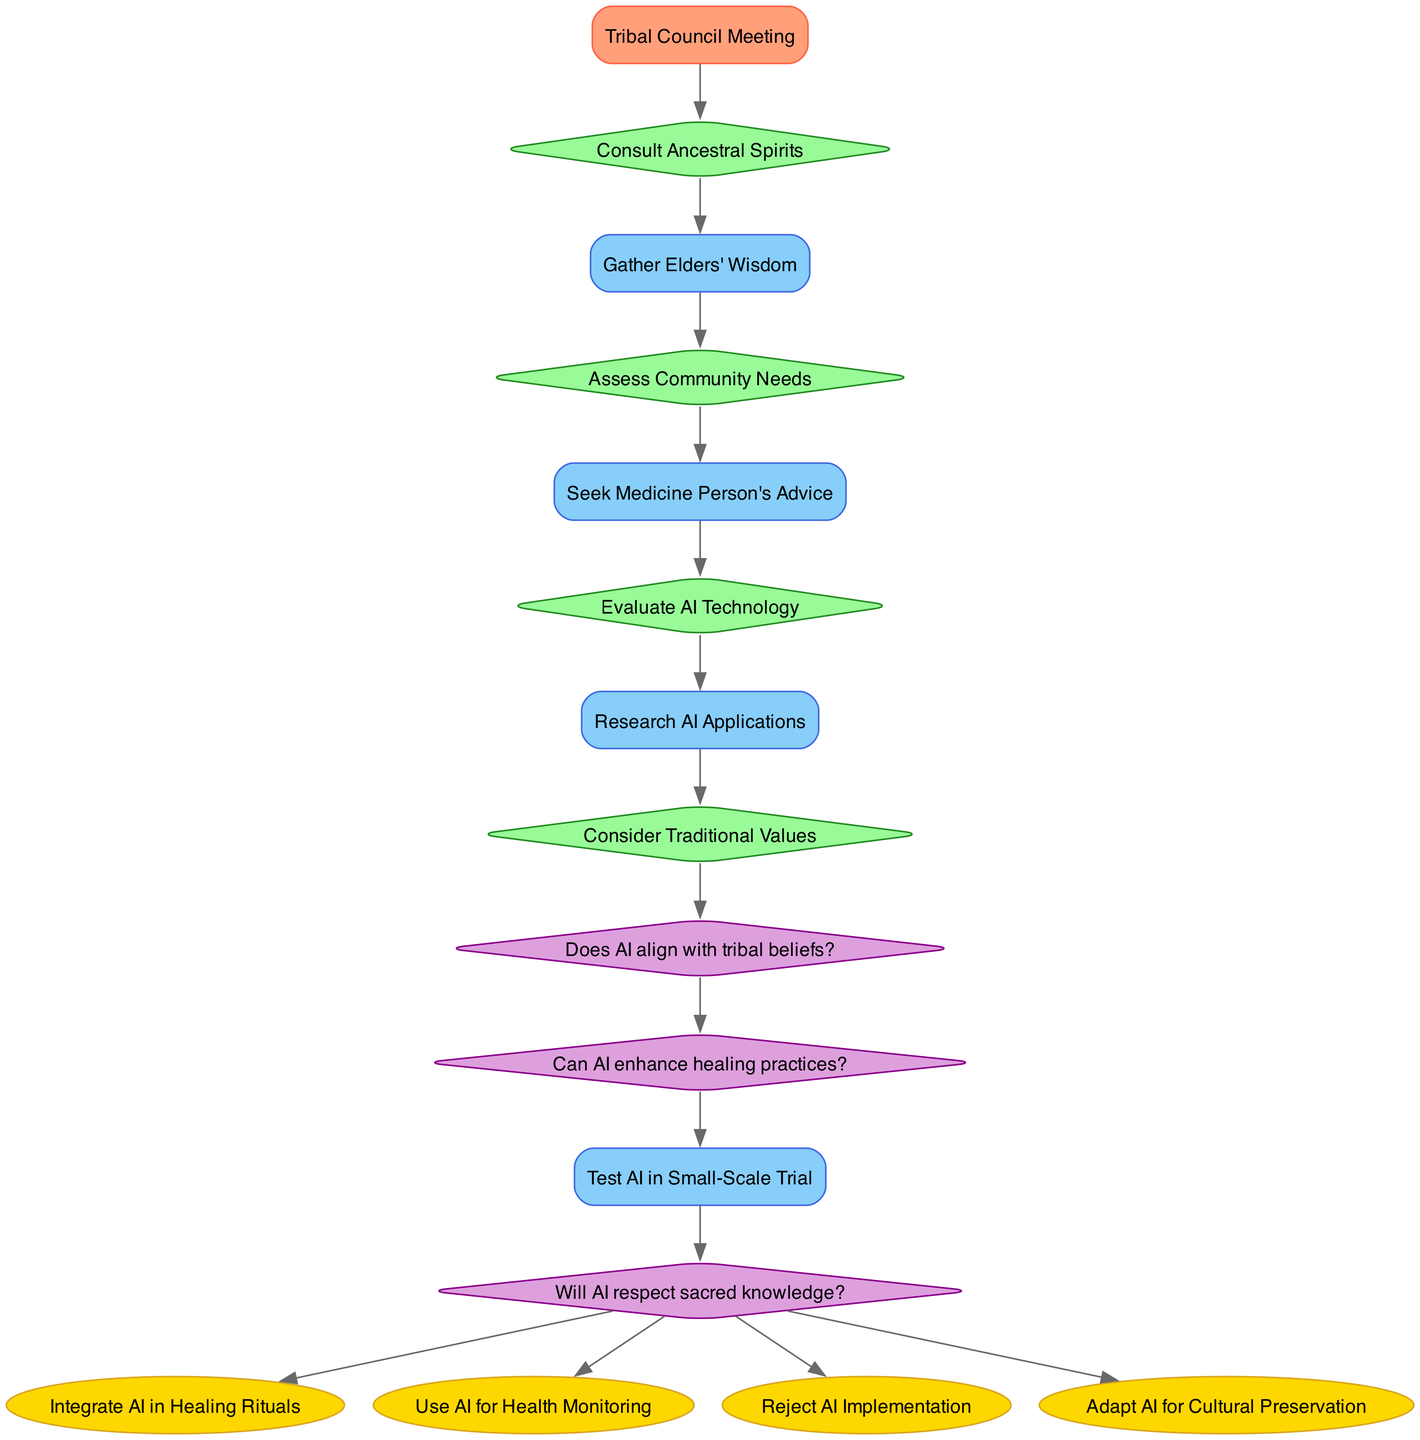What is the starting point of the decision-making process? The diagram indicates that the starting point is the "Tribal Council Meeting," as it is the first node in the flow.
Answer: Tribal Council Meeting How many decision nodes are there in the diagram? Counting the listed decision nodes, there are four: "Consult Ancestral Spirits," "Assess Community Needs," "Evaluate AI Technology," and "Consider Traditional Values."
Answer: 4 What comes after "Gather Elders' Wisdom" in the flow? After "Gather Elders' Wisdom," the next node is "Assess Community Needs," as shown by the connecting edge in the diagram.
Answer: Assess Community Needs Which outcome is reached if AI is deemed to respect sacred knowledge? If AI respects sacred knowledge, the diagram indicates that the outcomes would be "Integrate AI in Healing Rituals," "Use AI for Health Monitoring," "Reject AI Implementation," or "Adapt AI for Cultural Preservation" as possible paths.
Answer: Integrate AI in Healing Rituals, Use AI for Health Monitoring, Reject AI Implementation, Adapt AI for Cultural Preservation What decision point follows "Consider Traditional Values"? According to the flow, after "Consider Traditional Values," the next decision point is "Does AI align with tribal beliefs?" indicated by the connection in the diagram.
Answer: Does AI align with tribal beliefs? What is the relationship between "Evaluate AI Technology" and "Research AI Applications"? The diagram shows a direct connection from "Evaluate AI Technology" to "Research AI Applications," meaning that the latter is a subsequent step that follows the evaluation.
Answer: Direct connection If AI aligns with tribal beliefs and can enhance healing practices, what is the next step? Upon confirming both conditions, the flow indicates that "Test AI in Small-Scale Trial" is the next step to take in this decision-making process.
Answer: Test AI in Small-Scale Trial Which process involves seeking advice from a medicine person? The flow diagram specifies that seeking advice from a medicine person is represented in the process "Seek Medicine Person's Advice," which appears after assessing community needs.
Answer: Seek Medicine Person's Advice What is the outcome if the community decides to reject AI implementation? If the decision is to reject AI implementation, the corresponding outcome directly referenced in the diagram is "Reject AI Implementation."
Answer: Reject AI Implementation 